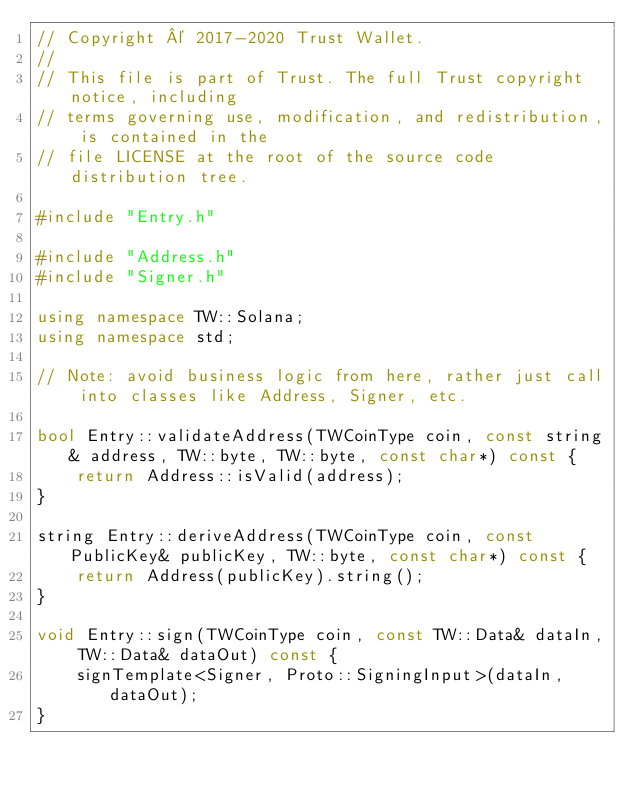Convert code to text. <code><loc_0><loc_0><loc_500><loc_500><_C++_>// Copyright © 2017-2020 Trust Wallet.
//
// This file is part of Trust. The full Trust copyright notice, including
// terms governing use, modification, and redistribution, is contained in the
// file LICENSE at the root of the source code distribution tree.

#include "Entry.h"

#include "Address.h"
#include "Signer.h"

using namespace TW::Solana;
using namespace std;

// Note: avoid business logic from here, rather just call into classes like Address, Signer, etc.

bool Entry::validateAddress(TWCoinType coin, const string& address, TW::byte, TW::byte, const char*) const {
    return Address::isValid(address);
}

string Entry::deriveAddress(TWCoinType coin, const PublicKey& publicKey, TW::byte, const char*) const {
    return Address(publicKey).string();
}

void Entry::sign(TWCoinType coin, const TW::Data& dataIn, TW::Data& dataOut) const {
    signTemplate<Signer, Proto::SigningInput>(dataIn, dataOut);
}
</code> 